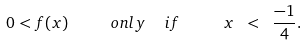<formula> <loc_0><loc_0><loc_500><loc_500>0 < f ( x ) \quad \ o n l y \ \ i f \quad \ x \ < \ \frac { - 1 } { 4 } .</formula> 